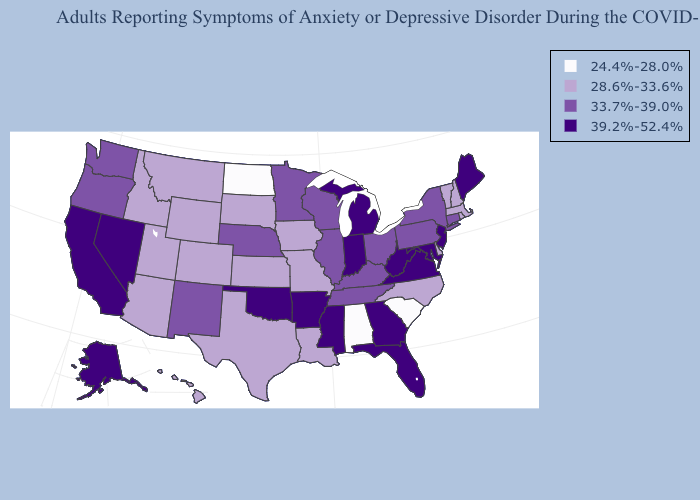Name the states that have a value in the range 24.4%-28.0%?
Write a very short answer. Alabama, North Dakota, South Carolina. Does Iowa have the highest value in the USA?
Write a very short answer. No. What is the highest value in the USA?
Answer briefly. 39.2%-52.4%. Among the states that border Texas , which have the highest value?
Keep it brief. Arkansas, Oklahoma. Name the states that have a value in the range 24.4%-28.0%?
Short answer required. Alabama, North Dakota, South Carolina. What is the lowest value in states that border South Carolina?
Quick response, please. 28.6%-33.6%. Does Virginia have a higher value than Rhode Island?
Concise answer only. Yes. Name the states that have a value in the range 33.7%-39.0%?
Give a very brief answer. Connecticut, Illinois, Kentucky, Minnesota, Nebraska, New Mexico, New York, Ohio, Oregon, Pennsylvania, Tennessee, Washington, Wisconsin. What is the value of Iowa?
Keep it brief. 28.6%-33.6%. What is the lowest value in the USA?
Short answer required. 24.4%-28.0%. What is the value of Georgia?
Answer briefly. 39.2%-52.4%. What is the value of Washington?
Give a very brief answer. 33.7%-39.0%. What is the value of New Hampshire?
Concise answer only. 28.6%-33.6%. What is the value of North Dakota?
Answer briefly. 24.4%-28.0%. Name the states that have a value in the range 24.4%-28.0%?
Concise answer only. Alabama, North Dakota, South Carolina. 